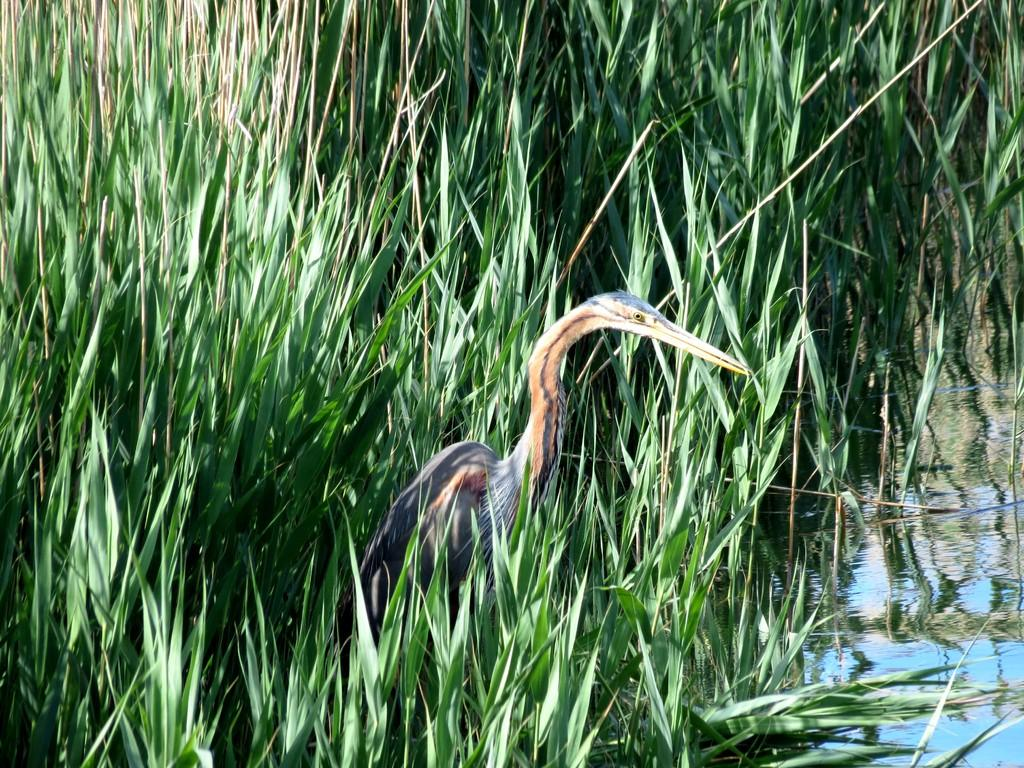What is the main subject in the foreground of the image? There is a bird in the foreground of the image. Where is the bird located? The bird is on the grass. What else can be seen in the image besides the bird? There is water visible in the image. Based on the presence of water and the bird, what might be the location of the image? The image was likely taken near a lake during the day. How many letters can be seen in the image? There are no letters visible in the image. Are there any children playing near the bird in the image? There is no mention of children in the provided facts, and therefore no children can be seen in the image. 